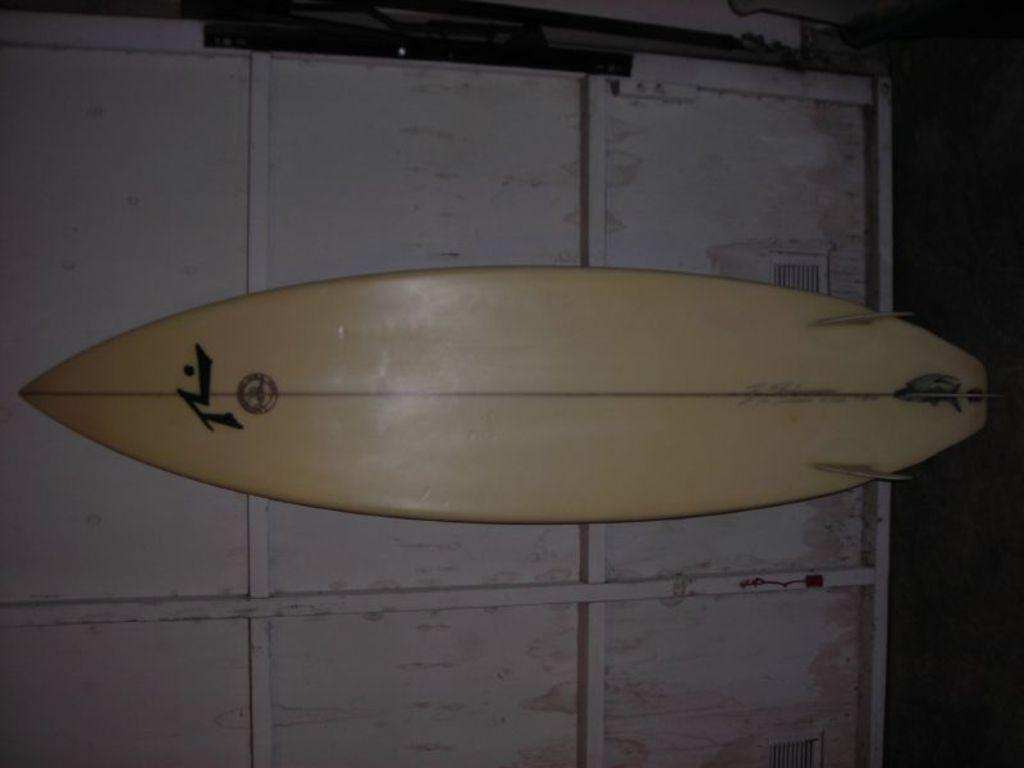What object is featured in the image? There is a surfing board in the image. Where is the surfing board located? The surfing board is kept on the wall. What type of scissors can be seen cutting the square in the image? There are no scissors or squares present in the image; it only features a surfing board on the wall. 